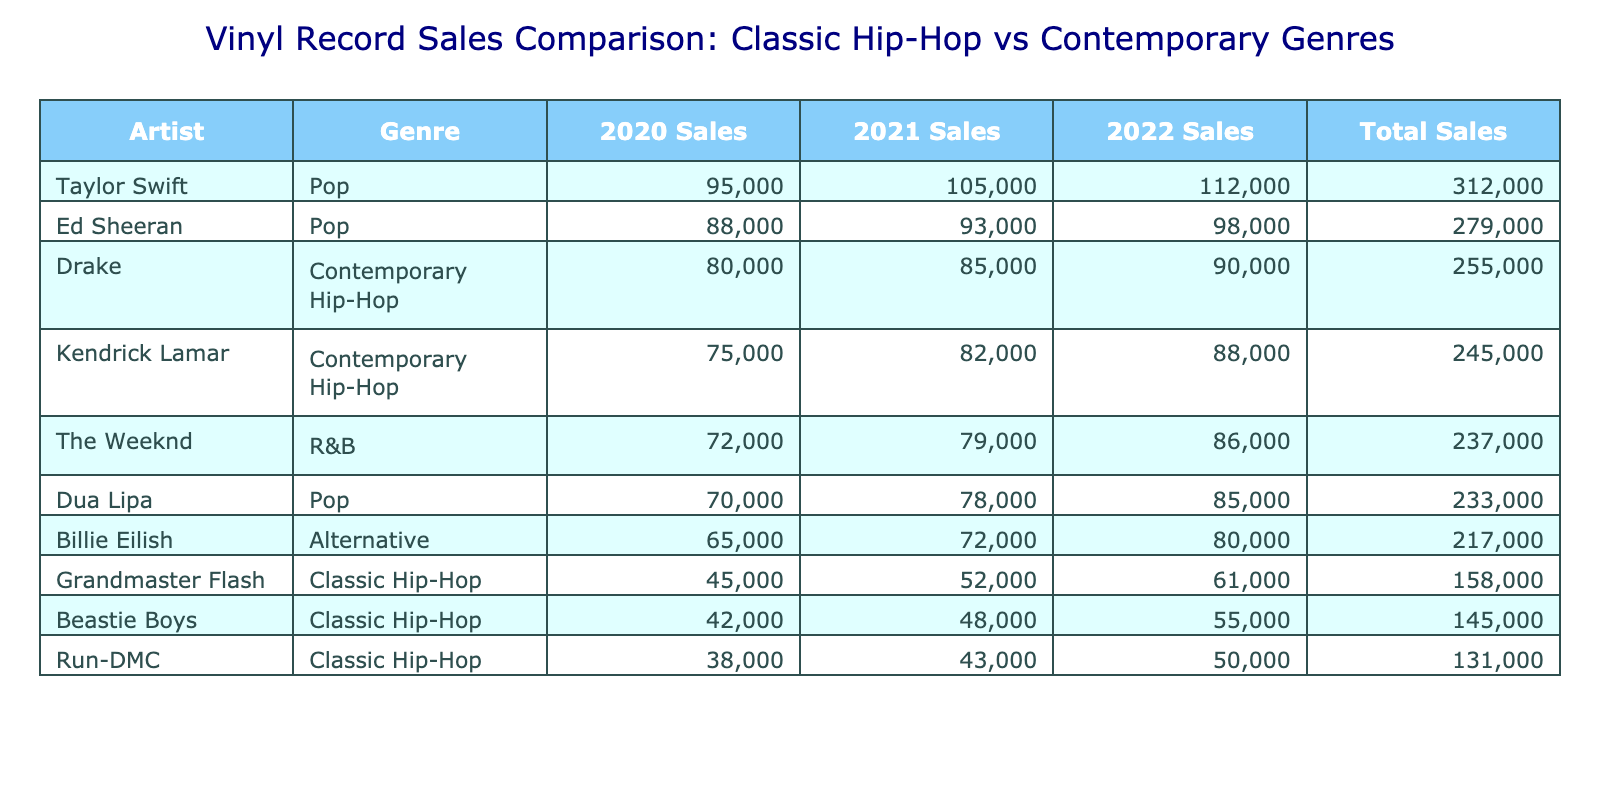What were Grandmaster Flash's total sales over the three years? Looking at the table, Grandmaster Flash had sales of 45000 in 2020, 52000 in 2021, and 61000 in 2022. Adding these together gives 45000 + 52000 + 61000 = 158000.
Answer: 158000 Which genre had the highest total sales? By summing the total sales for each genre, Classic Hip-Hop totals 45000 + 38000 + 42000 + 52000 + 43000 + 48000 + 61000 + 50000 = 334000. Contemporary Hip-Hop (Drake and Kendrick Lamar) totals 80000 + 75000 + 85000 + 82000 + 90000 + 88000 = 414000. Therefore, Contemporary Hip-Hop had the highest total.
Answer: Contemporary Hip-Hop Did Taylor Swift sell more vinyl records than any artist in the Classic Hip-Hop genre? Taylor Swift's total sales were 95000 + 105000 + 112000 = 312000. The highest sales in Classic Hip-Hop is Grandmaster Flash with 158000. Since 312000 is greater than 158000, the answer is yes.
Answer: Yes What is the average sales for Kendrick Lamar over the three years? Kendrick Lamar had sales of 75000 in 2020, 82000 in 2021, and 88000 in 2022. The sum of these sales is 75000 + 82000 + 88000 = 245000. To find the average, divide by 3, resulting in 245000 / 3 = 81666.67.
Answer: 81666.67 Which artist had the lowest sales in 2021? Checking the 2021 sales figures in the table, we see Run-DMC with 43000, Grandmaster Flash with 52000, and other artists have higher numbers. The lowest sales figure in 2021 is thus 43000 for Run-DMC.
Answer: Run-DMC 